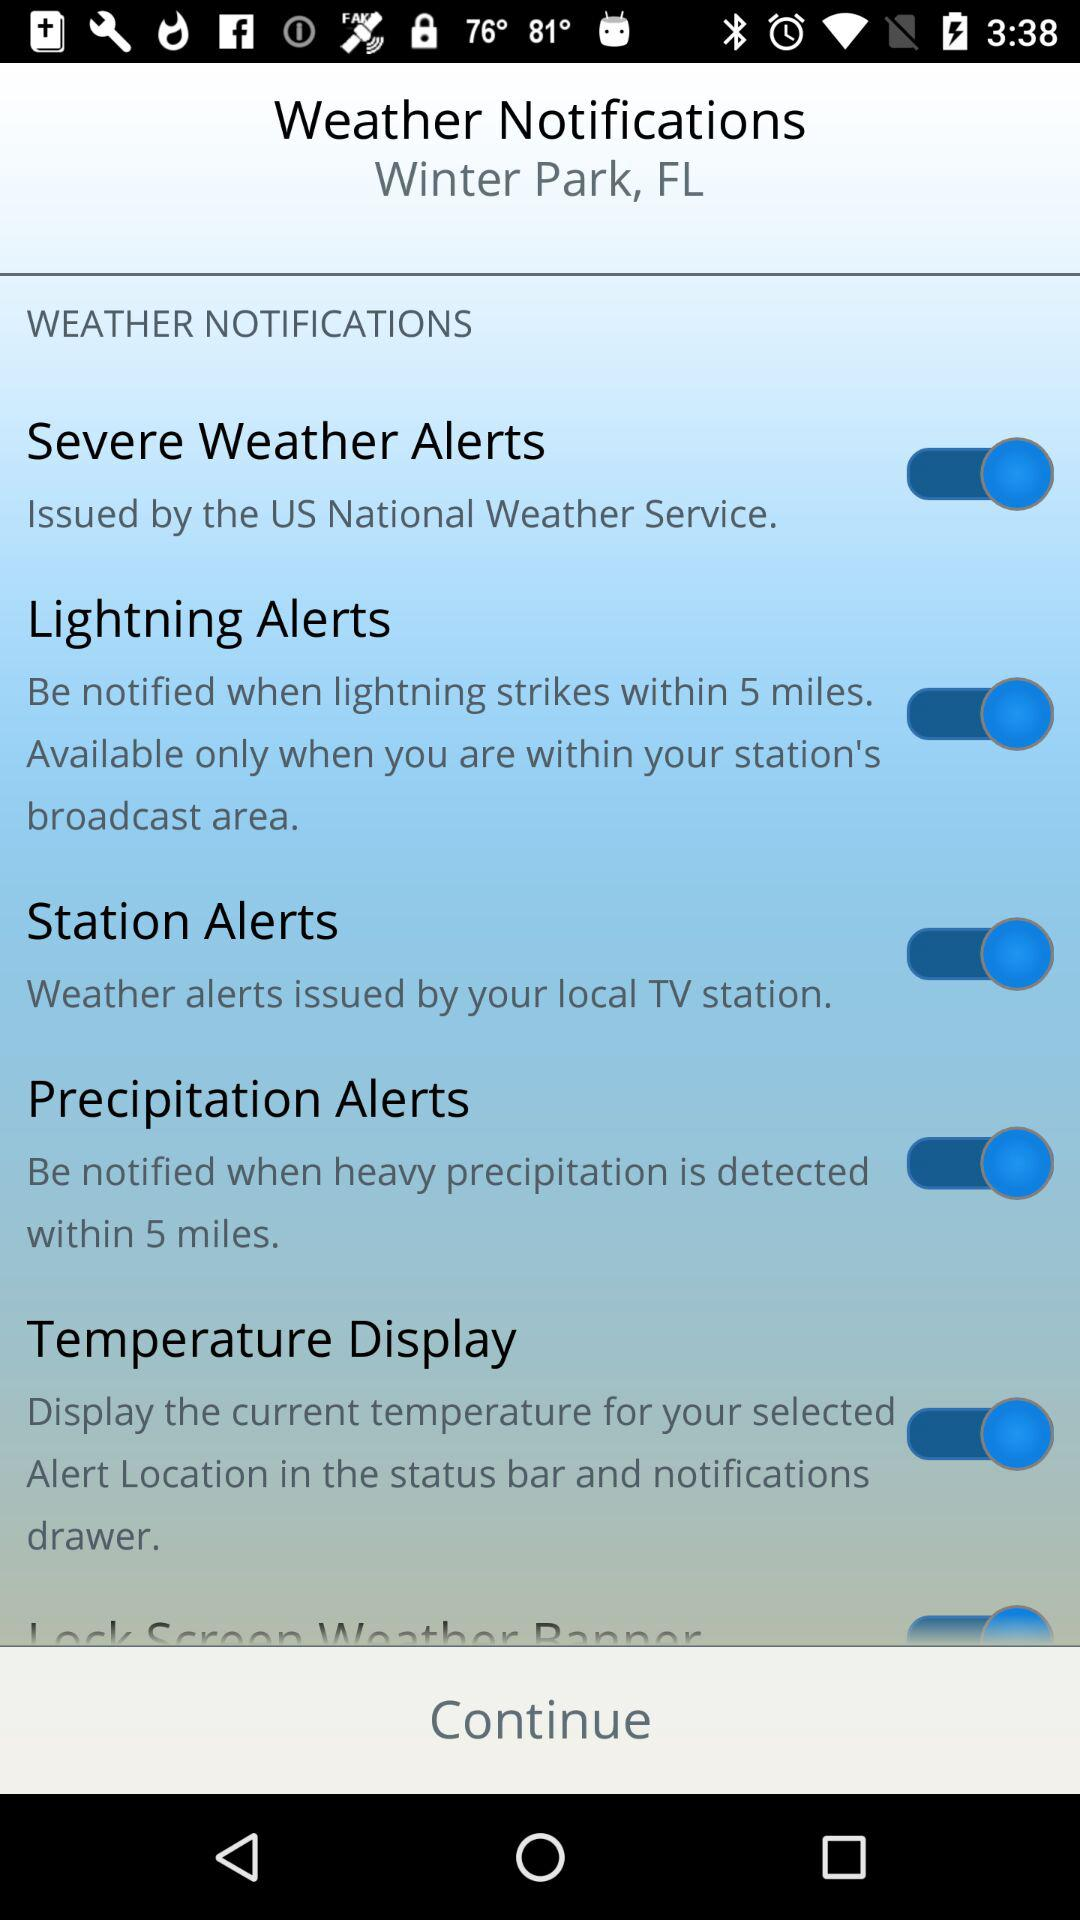What is the status of the "Lightning Alerts" notification? The status is "on". 